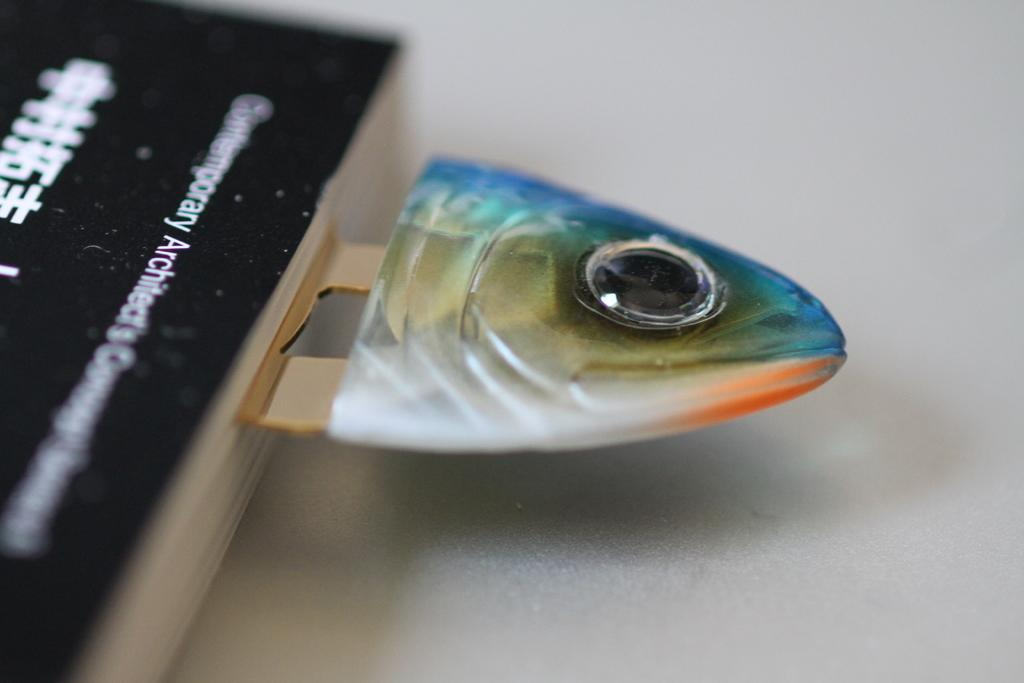What can be seen on the left side of the image? There is a book on the left side of the image. What type of object with a logo is present in the image? There is a metal object with a fish logo in the image. Where is the metal object located? The metal object is on a platform. What type of wood can be seen in the image? There is no wood present in the image. How many eggs are visible in the image? There are no eggs present in the image. 